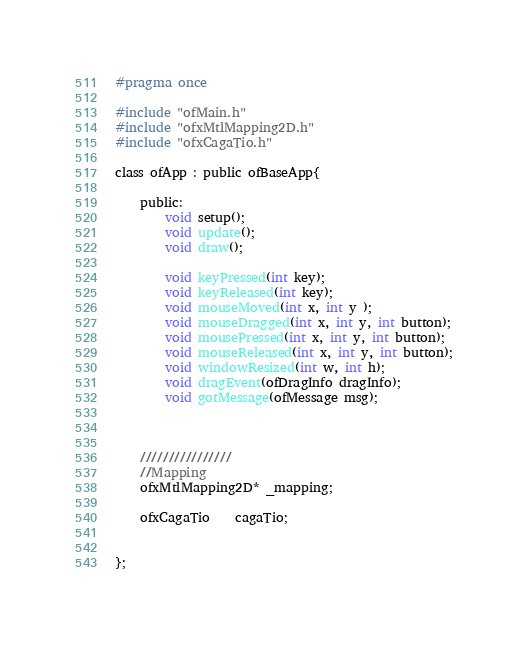<code> <loc_0><loc_0><loc_500><loc_500><_C_>#pragma once

#include "ofMain.h"
#include "ofxMtlMapping2D.h"
#include "ofxCagaTio.h"

class ofApp : public ofBaseApp{

	public:
		void setup();
		void update();
		void draw();

		void keyPressed(int key);
		void keyReleased(int key);
		void mouseMoved(int x, int y );
		void mouseDragged(int x, int y, int button);
		void mousePressed(int x, int y, int button);
		void mouseReleased(int x, int y, int button);
		void windowResized(int w, int h);
		void dragEvent(ofDragInfo dragInfo);
		void gotMessage(ofMessage msg);
	

		
	////////////////
	//Mapping
	ofxMtlMapping2D* _mapping;

	ofxCagaTio	cagaTio;
	
	
};
</code> 